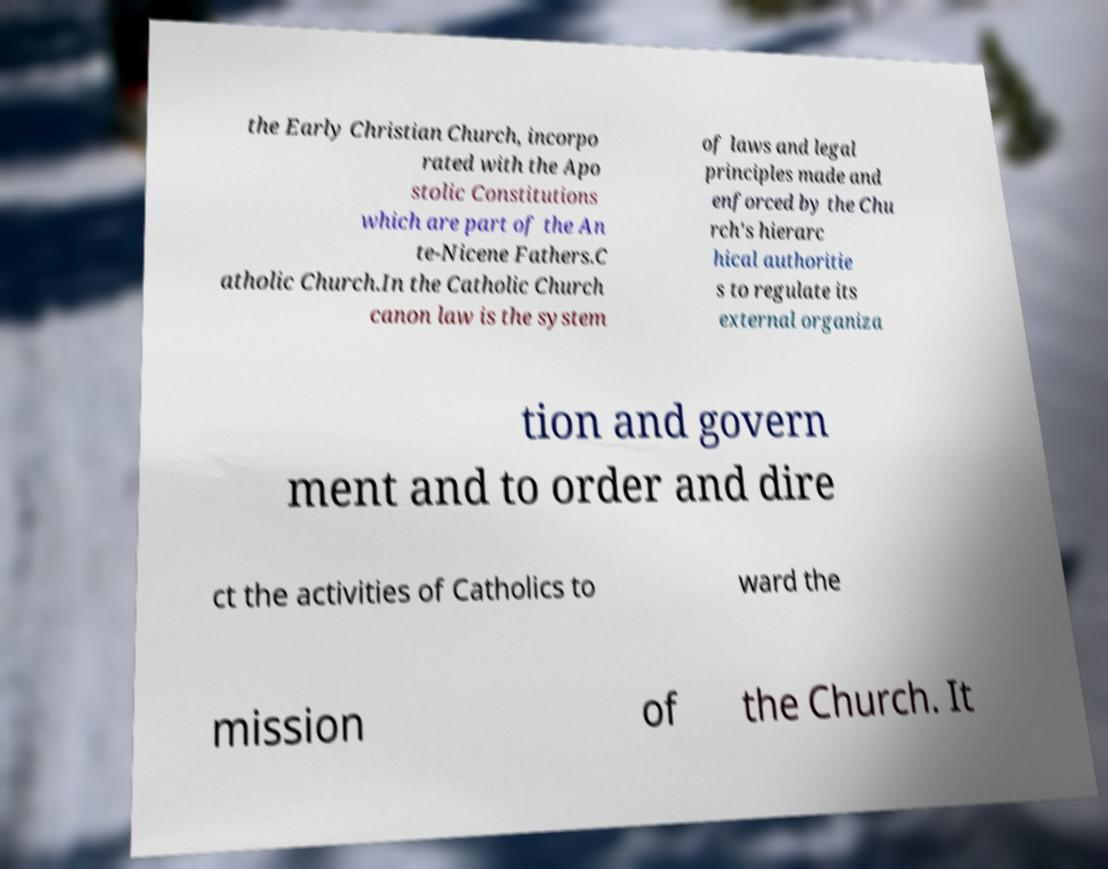Can you accurately transcribe the text from the provided image for me? the Early Christian Church, incorpo rated with the Apo stolic Constitutions which are part of the An te-Nicene Fathers.C atholic Church.In the Catholic Church canon law is the system of laws and legal principles made and enforced by the Chu rch's hierarc hical authoritie s to regulate its external organiza tion and govern ment and to order and dire ct the activities of Catholics to ward the mission of the Church. It 